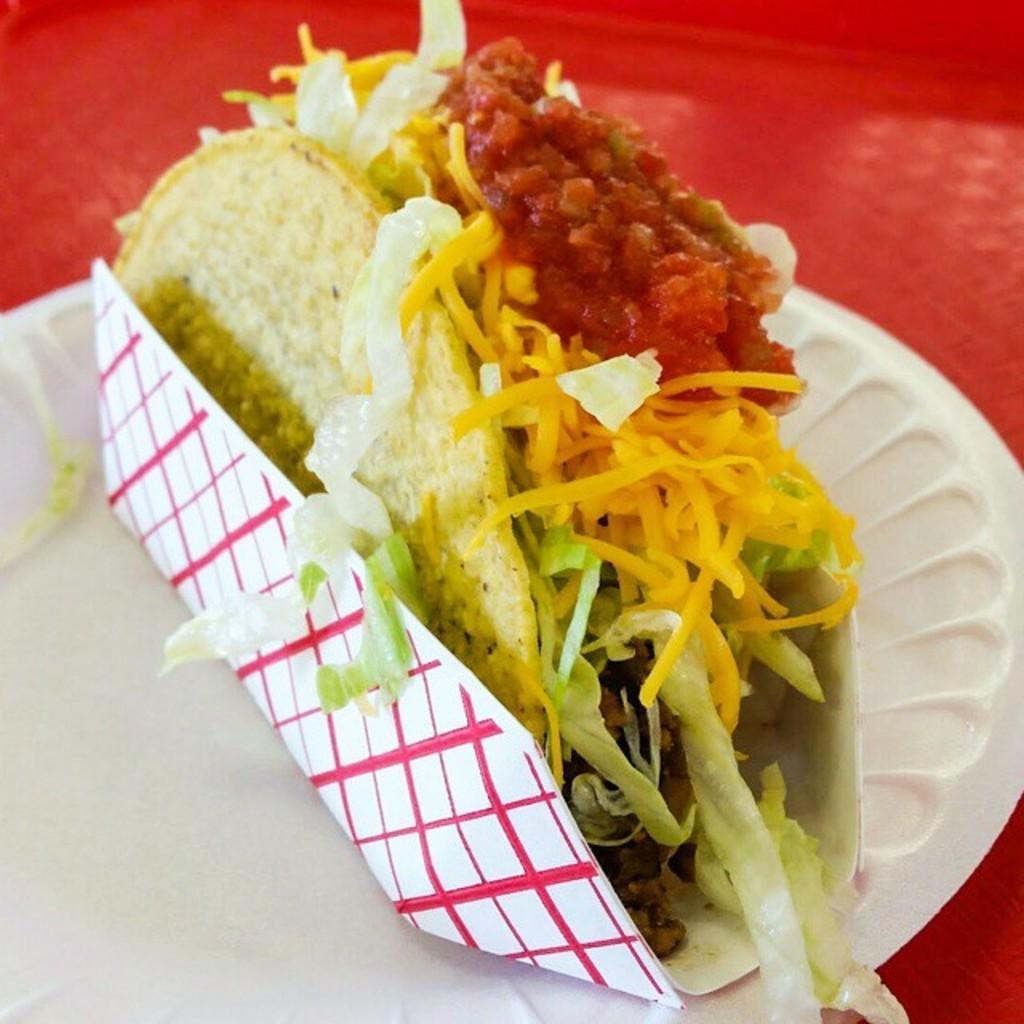How would you summarize this image in a sentence or two? In this picture I can see a eatable item is placed on the paper. 